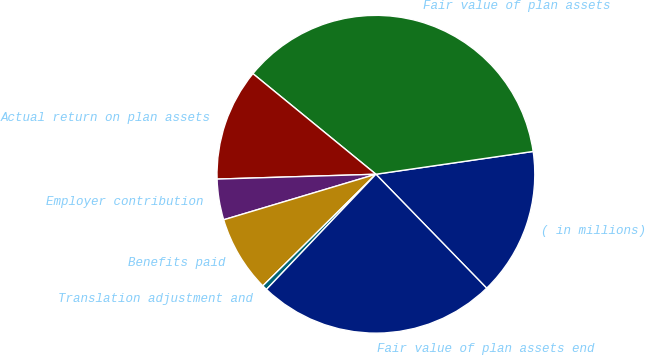<chart> <loc_0><loc_0><loc_500><loc_500><pie_chart><fcel>( in millions)<fcel>Fair value of plan assets<fcel>Actual return on plan assets<fcel>Employer contribution<fcel>Benefits paid<fcel>Translation adjustment and<fcel>Fair value of plan assets end<nl><fcel>15.02%<fcel>36.8%<fcel>11.4%<fcel>4.14%<fcel>7.77%<fcel>0.51%<fcel>24.37%<nl></chart> 